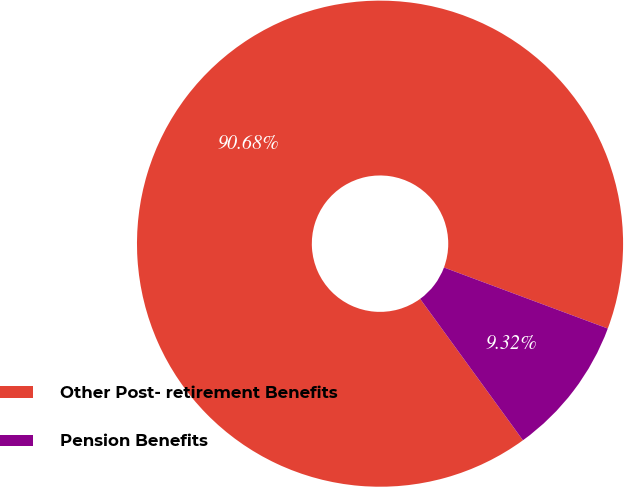<chart> <loc_0><loc_0><loc_500><loc_500><pie_chart><fcel>Other Post- retirement Benefits<fcel>Pension Benefits<nl><fcel>90.68%<fcel>9.32%<nl></chart> 